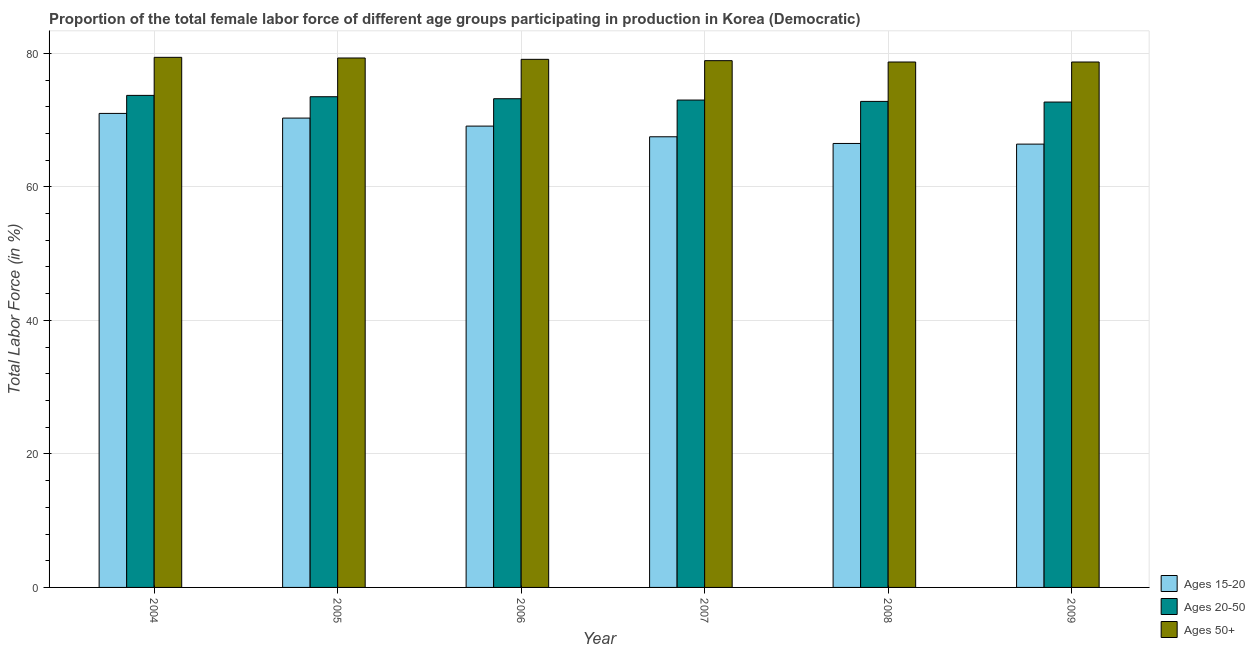Are the number of bars per tick equal to the number of legend labels?
Offer a very short reply. Yes. Are the number of bars on each tick of the X-axis equal?
Keep it short and to the point. Yes. How many bars are there on the 1st tick from the left?
Your answer should be compact. 3. How many bars are there on the 6th tick from the right?
Give a very brief answer. 3. What is the label of the 6th group of bars from the left?
Provide a succinct answer. 2009. Across all years, what is the maximum percentage of female labor force within the age group 15-20?
Your answer should be compact. 71. Across all years, what is the minimum percentage of female labor force within the age group 15-20?
Offer a very short reply. 66.4. In which year was the percentage of female labor force above age 50 maximum?
Offer a very short reply. 2004. In which year was the percentage of female labor force above age 50 minimum?
Provide a succinct answer. 2008. What is the total percentage of female labor force within the age group 20-50 in the graph?
Keep it short and to the point. 438.9. What is the difference between the percentage of female labor force within the age group 15-20 in 2009 and the percentage of female labor force above age 50 in 2005?
Provide a short and direct response. -3.9. What is the average percentage of female labor force within the age group 15-20 per year?
Your answer should be very brief. 68.47. In how many years, is the percentage of female labor force above age 50 greater than 32 %?
Provide a short and direct response. 6. What is the ratio of the percentage of female labor force above age 50 in 2007 to that in 2008?
Your response must be concise. 1. Is the percentage of female labor force above age 50 in 2004 less than that in 2008?
Give a very brief answer. No. What is the difference between the highest and the second highest percentage of female labor force within the age group 15-20?
Your response must be concise. 0.7. In how many years, is the percentage of female labor force within the age group 20-50 greater than the average percentage of female labor force within the age group 20-50 taken over all years?
Make the answer very short. 3. Is the sum of the percentage of female labor force above age 50 in 2006 and 2008 greater than the maximum percentage of female labor force within the age group 20-50 across all years?
Your answer should be very brief. Yes. What does the 2nd bar from the left in 2009 represents?
Give a very brief answer. Ages 20-50. What does the 2nd bar from the right in 2008 represents?
Your answer should be compact. Ages 20-50. Is it the case that in every year, the sum of the percentage of female labor force within the age group 15-20 and percentage of female labor force within the age group 20-50 is greater than the percentage of female labor force above age 50?
Make the answer very short. Yes. Are all the bars in the graph horizontal?
Provide a succinct answer. No. How many years are there in the graph?
Give a very brief answer. 6. What is the difference between two consecutive major ticks on the Y-axis?
Ensure brevity in your answer.  20. Does the graph contain grids?
Offer a terse response. Yes. Where does the legend appear in the graph?
Your answer should be compact. Bottom right. How are the legend labels stacked?
Keep it short and to the point. Vertical. What is the title of the graph?
Provide a succinct answer. Proportion of the total female labor force of different age groups participating in production in Korea (Democratic). Does "Czech Republic" appear as one of the legend labels in the graph?
Give a very brief answer. No. What is the label or title of the Y-axis?
Provide a succinct answer. Total Labor Force (in %). What is the Total Labor Force (in %) of Ages 15-20 in 2004?
Make the answer very short. 71. What is the Total Labor Force (in %) in Ages 20-50 in 2004?
Your answer should be very brief. 73.7. What is the Total Labor Force (in %) in Ages 50+ in 2004?
Offer a terse response. 79.4. What is the Total Labor Force (in %) in Ages 15-20 in 2005?
Provide a short and direct response. 70.3. What is the Total Labor Force (in %) of Ages 20-50 in 2005?
Keep it short and to the point. 73.5. What is the Total Labor Force (in %) in Ages 50+ in 2005?
Give a very brief answer. 79.3. What is the Total Labor Force (in %) of Ages 15-20 in 2006?
Your response must be concise. 69.1. What is the Total Labor Force (in %) in Ages 20-50 in 2006?
Offer a terse response. 73.2. What is the Total Labor Force (in %) in Ages 50+ in 2006?
Ensure brevity in your answer.  79.1. What is the Total Labor Force (in %) of Ages 15-20 in 2007?
Offer a very short reply. 67.5. What is the Total Labor Force (in %) of Ages 20-50 in 2007?
Offer a terse response. 73. What is the Total Labor Force (in %) in Ages 50+ in 2007?
Offer a very short reply. 78.9. What is the Total Labor Force (in %) in Ages 15-20 in 2008?
Your answer should be compact. 66.5. What is the Total Labor Force (in %) in Ages 20-50 in 2008?
Provide a short and direct response. 72.8. What is the Total Labor Force (in %) of Ages 50+ in 2008?
Offer a very short reply. 78.7. What is the Total Labor Force (in %) of Ages 15-20 in 2009?
Give a very brief answer. 66.4. What is the Total Labor Force (in %) in Ages 20-50 in 2009?
Your response must be concise. 72.7. What is the Total Labor Force (in %) in Ages 50+ in 2009?
Ensure brevity in your answer.  78.7. Across all years, what is the maximum Total Labor Force (in %) of Ages 20-50?
Offer a very short reply. 73.7. Across all years, what is the maximum Total Labor Force (in %) of Ages 50+?
Provide a succinct answer. 79.4. Across all years, what is the minimum Total Labor Force (in %) of Ages 15-20?
Your answer should be compact. 66.4. Across all years, what is the minimum Total Labor Force (in %) in Ages 20-50?
Provide a short and direct response. 72.7. Across all years, what is the minimum Total Labor Force (in %) of Ages 50+?
Your answer should be very brief. 78.7. What is the total Total Labor Force (in %) in Ages 15-20 in the graph?
Keep it short and to the point. 410.8. What is the total Total Labor Force (in %) in Ages 20-50 in the graph?
Your response must be concise. 438.9. What is the total Total Labor Force (in %) in Ages 50+ in the graph?
Your answer should be very brief. 474.1. What is the difference between the Total Labor Force (in %) of Ages 15-20 in 2004 and that in 2005?
Your answer should be very brief. 0.7. What is the difference between the Total Labor Force (in %) in Ages 20-50 in 2004 and that in 2006?
Your response must be concise. 0.5. What is the difference between the Total Labor Force (in %) of Ages 15-20 in 2004 and that in 2008?
Your response must be concise. 4.5. What is the difference between the Total Labor Force (in %) of Ages 20-50 in 2004 and that in 2009?
Your response must be concise. 1. What is the difference between the Total Labor Force (in %) of Ages 50+ in 2004 and that in 2009?
Make the answer very short. 0.7. What is the difference between the Total Labor Force (in %) of Ages 15-20 in 2005 and that in 2006?
Give a very brief answer. 1.2. What is the difference between the Total Labor Force (in %) of Ages 20-50 in 2005 and that in 2006?
Your answer should be compact. 0.3. What is the difference between the Total Labor Force (in %) of Ages 50+ in 2005 and that in 2006?
Make the answer very short. 0.2. What is the difference between the Total Labor Force (in %) of Ages 15-20 in 2005 and that in 2007?
Provide a short and direct response. 2.8. What is the difference between the Total Labor Force (in %) in Ages 50+ in 2005 and that in 2007?
Ensure brevity in your answer.  0.4. What is the difference between the Total Labor Force (in %) in Ages 15-20 in 2005 and that in 2008?
Your answer should be very brief. 3.8. What is the difference between the Total Labor Force (in %) of Ages 20-50 in 2005 and that in 2008?
Your answer should be very brief. 0.7. What is the difference between the Total Labor Force (in %) of Ages 15-20 in 2005 and that in 2009?
Make the answer very short. 3.9. What is the difference between the Total Labor Force (in %) of Ages 50+ in 2005 and that in 2009?
Give a very brief answer. 0.6. What is the difference between the Total Labor Force (in %) of Ages 20-50 in 2006 and that in 2007?
Give a very brief answer. 0.2. What is the difference between the Total Labor Force (in %) in Ages 50+ in 2006 and that in 2007?
Keep it short and to the point. 0.2. What is the difference between the Total Labor Force (in %) in Ages 15-20 in 2006 and that in 2008?
Your response must be concise. 2.6. What is the difference between the Total Labor Force (in %) of Ages 20-50 in 2006 and that in 2008?
Offer a terse response. 0.4. What is the difference between the Total Labor Force (in %) of Ages 15-20 in 2008 and that in 2009?
Provide a succinct answer. 0.1. What is the difference between the Total Labor Force (in %) in Ages 20-50 in 2008 and that in 2009?
Your answer should be very brief. 0.1. What is the difference between the Total Labor Force (in %) in Ages 15-20 in 2004 and the Total Labor Force (in %) in Ages 20-50 in 2005?
Give a very brief answer. -2.5. What is the difference between the Total Labor Force (in %) in Ages 15-20 in 2004 and the Total Labor Force (in %) in Ages 50+ in 2005?
Provide a succinct answer. -8.3. What is the difference between the Total Labor Force (in %) in Ages 15-20 in 2004 and the Total Labor Force (in %) in Ages 20-50 in 2006?
Offer a very short reply. -2.2. What is the difference between the Total Labor Force (in %) in Ages 15-20 in 2004 and the Total Labor Force (in %) in Ages 20-50 in 2007?
Ensure brevity in your answer.  -2. What is the difference between the Total Labor Force (in %) of Ages 15-20 in 2004 and the Total Labor Force (in %) of Ages 50+ in 2008?
Make the answer very short. -7.7. What is the difference between the Total Labor Force (in %) in Ages 15-20 in 2004 and the Total Labor Force (in %) in Ages 50+ in 2009?
Provide a short and direct response. -7.7. What is the difference between the Total Labor Force (in %) of Ages 15-20 in 2005 and the Total Labor Force (in %) of Ages 50+ in 2007?
Your answer should be very brief. -8.6. What is the difference between the Total Labor Force (in %) of Ages 15-20 in 2005 and the Total Labor Force (in %) of Ages 50+ in 2008?
Provide a short and direct response. -8.4. What is the difference between the Total Labor Force (in %) of Ages 20-50 in 2005 and the Total Labor Force (in %) of Ages 50+ in 2008?
Keep it short and to the point. -5.2. What is the difference between the Total Labor Force (in %) in Ages 15-20 in 2007 and the Total Labor Force (in %) in Ages 20-50 in 2008?
Offer a terse response. -5.3. What is the difference between the Total Labor Force (in %) in Ages 20-50 in 2007 and the Total Labor Force (in %) in Ages 50+ in 2008?
Give a very brief answer. -5.7. What is the difference between the Total Labor Force (in %) of Ages 15-20 in 2007 and the Total Labor Force (in %) of Ages 20-50 in 2009?
Provide a succinct answer. -5.2. What is the difference between the Total Labor Force (in %) in Ages 15-20 in 2008 and the Total Labor Force (in %) in Ages 50+ in 2009?
Ensure brevity in your answer.  -12.2. What is the average Total Labor Force (in %) of Ages 15-20 per year?
Your answer should be compact. 68.47. What is the average Total Labor Force (in %) in Ages 20-50 per year?
Your answer should be compact. 73.15. What is the average Total Labor Force (in %) in Ages 50+ per year?
Your response must be concise. 79.02. In the year 2004, what is the difference between the Total Labor Force (in %) in Ages 15-20 and Total Labor Force (in %) in Ages 50+?
Keep it short and to the point. -8.4. In the year 2005, what is the difference between the Total Labor Force (in %) of Ages 20-50 and Total Labor Force (in %) of Ages 50+?
Your answer should be very brief. -5.8. In the year 2006, what is the difference between the Total Labor Force (in %) in Ages 15-20 and Total Labor Force (in %) in Ages 50+?
Your response must be concise. -10. In the year 2007, what is the difference between the Total Labor Force (in %) of Ages 15-20 and Total Labor Force (in %) of Ages 20-50?
Your response must be concise. -5.5. In the year 2007, what is the difference between the Total Labor Force (in %) in Ages 15-20 and Total Labor Force (in %) in Ages 50+?
Keep it short and to the point. -11.4. In the year 2007, what is the difference between the Total Labor Force (in %) of Ages 20-50 and Total Labor Force (in %) of Ages 50+?
Make the answer very short. -5.9. In the year 2008, what is the difference between the Total Labor Force (in %) in Ages 15-20 and Total Labor Force (in %) in Ages 20-50?
Make the answer very short. -6.3. In the year 2008, what is the difference between the Total Labor Force (in %) in Ages 20-50 and Total Labor Force (in %) in Ages 50+?
Keep it short and to the point. -5.9. What is the ratio of the Total Labor Force (in %) of Ages 15-20 in 2004 to that in 2005?
Your response must be concise. 1.01. What is the ratio of the Total Labor Force (in %) of Ages 15-20 in 2004 to that in 2006?
Provide a short and direct response. 1.03. What is the ratio of the Total Labor Force (in %) of Ages 20-50 in 2004 to that in 2006?
Offer a terse response. 1.01. What is the ratio of the Total Labor Force (in %) of Ages 15-20 in 2004 to that in 2007?
Offer a terse response. 1.05. What is the ratio of the Total Labor Force (in %) in Ages 20-50 in 2004 to that in 2007?
Ensure brevity in your answer.  1.01. What is the ratio of the Total Labor Force (in %) in Ages 50+ in 2004 to that in 2007?
Make the answer very short. 1.01. What is the ratio of the Total Labor Force (in %) in Ages 15-20 in 2004 to that in 2008?
Provide a short and direct response. 1.07. What is the ratio of the Total Labor Force (in %) of Ages 20-50 in 2004 to that in 2008?
Provide a succinct answer. 1.01. What is the ratio of the Total Labor Force (in %) of Ages 50+ in 2004 to that in 2008?
Your answer should be compact. 1.01. What is the ratio of the Total Labor Force (in %) of Ages 15-20 in 2004 to that in 2009?
Your response must be concise. 1.07. What is the ratio of the Total Labor Force (in %) of Ages 20-50 in 2004 to that in 2009?
Make the answer very short. 1.01. What is the ratio of the Total Labor Force (in %) in Ages 50+ in 2004 to that in 2009?
Your answer should be very brief. 1.01. What is the ratio of the Total Labor Force (in %) of Ages 15-20 in 2005 to that in 2006?
Provide a succinct answer. 1.02. What is the ratio of the Total Labor Force (in %) of Ages 20-50 in 2005 to that in 2006?
Your answer should be compact. 1. What is the ratio of the Total Labor Force (in %) of Ages 15-20 in 2005 to that in 2007?
Offer a terse response. 1.04. What is the ratio of the Total Labor Force (in %) in Ages 20-50 in 2005 to that in 2007?
Your answer should be compact. 1.01. What is the ratio of the Total Labor Force (in %) in Ages 50+ in 2005 to that in 2007?
Ensure brevity in your answer.  1.01. What is the ratio of the Total Labor Force (in %) of Ages 15-20 in 2005 to that in 2008?
Provide a short and direct response. 1.06. What is the ratio of the Total Labor Force (in %) in Ages 20-50 in 2005 to that in 2008?
Ensure brevity in your answer.  1.01. What is the ratio of the Total Labor Force (in %) of Ages 50+ in 2005 to that in 2008?
Provide a short and direct response. 1.01. What is the ratio of the Total Labor Force (in %) in Ages 15-20 in 2005 to that in 2009?
Provide a short and direct response. 1.06. What is the ratio of the Total Labor Force (in %) in Ages 20-50 in 2005 to that in 2009?
Offer a very short reply. 1.01. What is the ratio of the Total Labor Force (in %) in Ages 50+ in 2005 to that in 2009?
Your answer should be very brief. 1.01. What is the ratio of the Total Labor Force (in %) of Ages 15-20 in 2006 to that in 2007?
Your answer should be very brief. 1.02. What is the ratio of the Total Labor Force (in %) of Ages 50+ in 2006 to that in 2007?
Make the answer very short. 1. What is the ratio of the Total Labor Force (in %) in Ages 15-20 in 2006 to that in 2008?
Make the answer very short. 1.04. What is the ratio of the Total Labor Force (in %) of Ages 50+ in 2006 to that in 2008?
Offer a terse response. 1.01. What is the ratio of the Total Labor Force (in %) of Ages 15-20 in 2006 to that in 2009?
Provide a succinct answer. 1.04. What is the ratio of the Total Labor Force (in %) of Ages 20-50 in 2006 to that in 2009?
Give a very brief answer. 1.01. What is the ratio of the Total Labor Force (in %) in Ages 50+ in 2006 to that in 2009?
Provide a succinct answer. 1.01. What is the ratio of the Total Labor Force (in %) in Ages 15-20 in 2007 to that in 2008?
Your response must be concise. 1.01. What is the ratio of the Total Labor Force (in %) of Ages 15-20 in 2007 to that in 2009?
Give a very brief answer. 1.02. What is the ratio of the Total Labor Force (in %) of Ages 20-50 in 2008 to that in 2009?
Ensure brevity in your answer.  1. What is the difference between the highest and the second highest Total Labor Force (in %) of Ages 15-20?
Provide a short and direct response. 0.7. What is the difference between the highest and the second highest Total Labor Force (in %) of Ages 50+?
Provide a short and direct response. 0.1. What is the difference between the highest and the lowest Total Labor Force (in %) in Ages 15-20?
Offer a terse response. 4.6. What is the difference between the highest and the lowest Total Labor Force (in %) in Ages 20-50?
Your answer should be compact. 1. What is the difference between the highest and the lowest Total Labor Force (in %) in Ages 50+?
Keep it short and to the point. 0.7. 